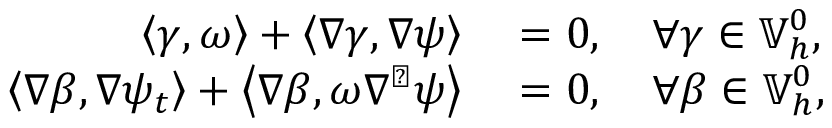<formula> <loc_0><loc_0><loc_500><loc_500>\begin{array} { r l } { \left \langle \gamma , \omega \right \rangle + \left \langle \nabla \gamma , \nabla \psi \right \rangle } & = 0 , \quad \forall \gamma \in \mathbb { V } _ { h } ^ { 0 } , } \\ { \left \langle \nabla \beta , \nabla \psi _ { t } \right \rangle + \left \langle \nabla \beta , \omega \nabla ^ { \perp } \psi \right \rangle } & = 0 , \quad \forall \beta \in \mathbb { V } _ { h } ^ { 0 } , } \end{array}</formula> 